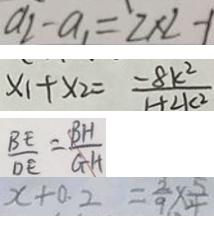<formula> <loc_0><loc_0><loc_500><loc_500>a _ { 2 } - a _ { 1 } = ^ { \prime } 2 \times 2 - 1 
 x _ { 1 } + x _ { 2 } = \frac { - 8 k ^ { 2 } } { 1 + 2 k ^ { 2 } } 
 \frac { B E } { D E } = \frac { B H } { G H } 
 x + 0 . 2 = \frac { 2 } { 9 } \times \frac { 5 } { 4 }</formula> 